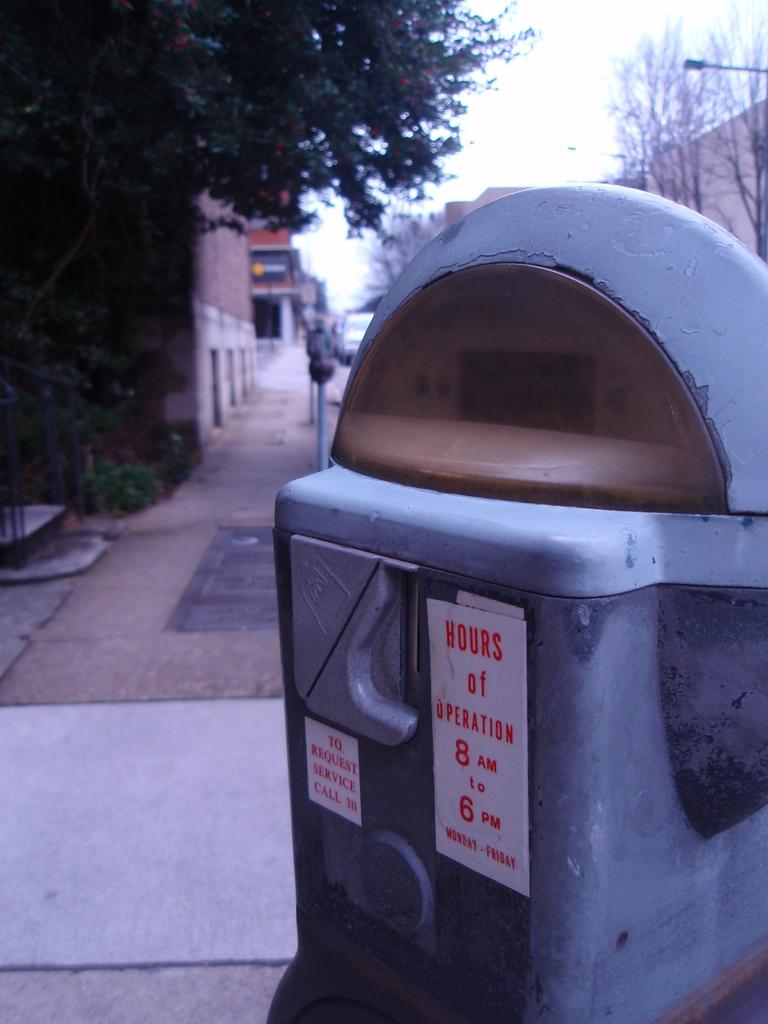<image>
Offer a succinct explanation of the picture presented. a parking meter that has a sign that says 'hours of operation' on it 